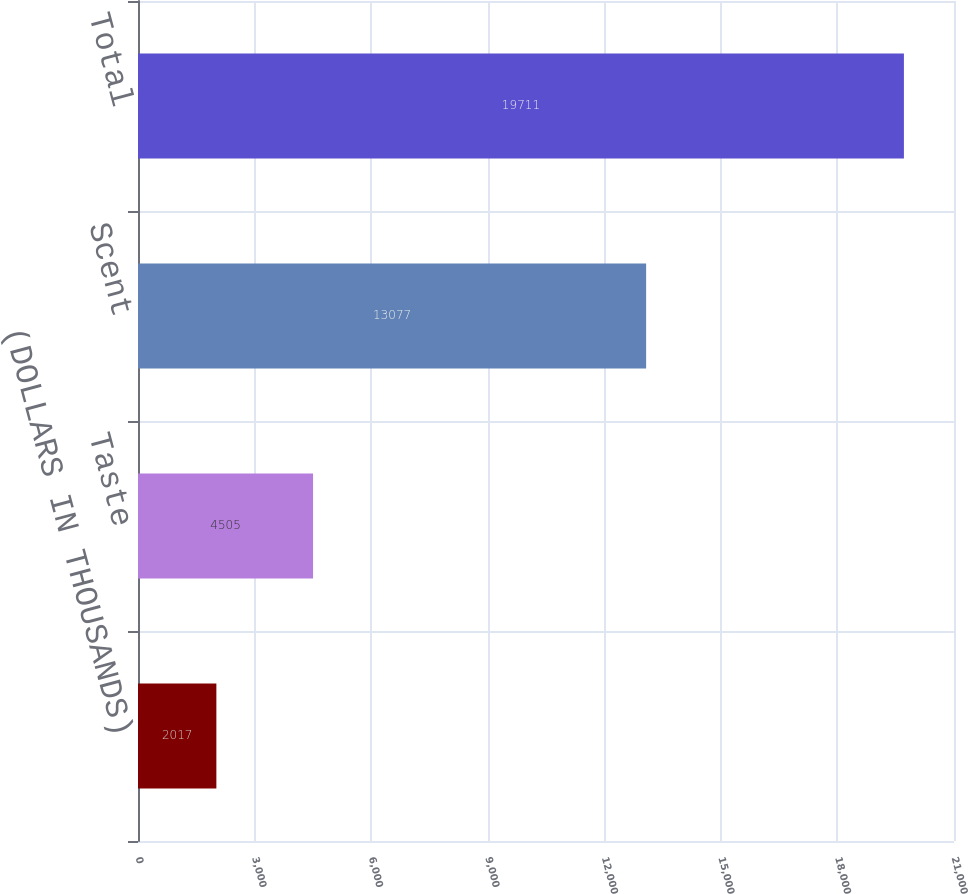<chart> <loc_0><loc_0><loc_500><loc_500><bar_chart><fcel>(DOLLARS IN THOUSANDS)<fcel>Taste<fcel>Scent<fcel>Total<nl><fcel>2017<fcel>4505<fcel>13077<fcel>19711<nl></chart> 